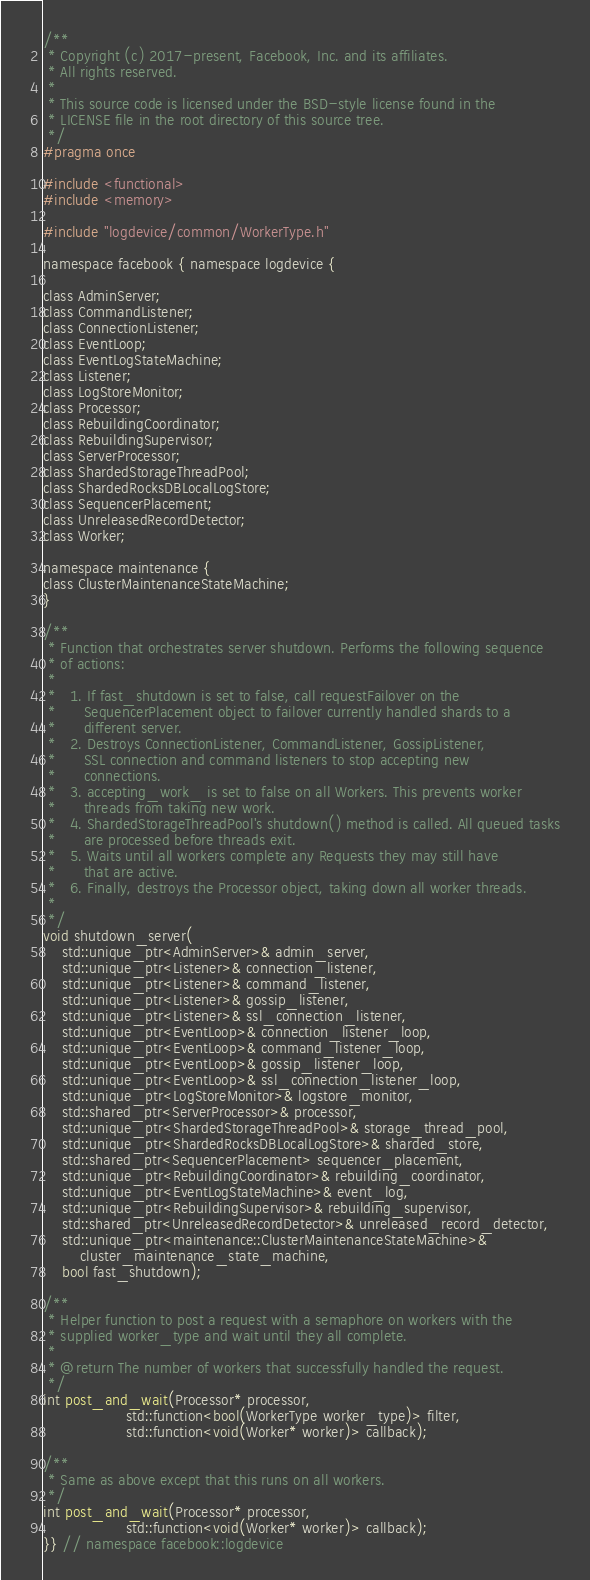<code> <loc_0><loc_0><loc_500><loc_500><_C_>/**
 * Copyright (c) 2017-present, Facebook, Inc. and its affiliates.
 * All rights reserved.
 *
 * This source code is licensed under the BSD-style license found in the
 * LICENSE file in the root directory of this source tree.
 */
#pragma once

#include <functional>
#include <memory>

#include "logdevice/common/WorkerType.h"

namespace facebook { namespace logdevice {

class AdminServer;
class CommandListener;
class ConnectionListener;
class EventLoop;
class EventLogStateMachine;
class Listener;
class LogStoreMonitor;
class Processor;
class RebuildingCoordinator;
class RebuildingSupervisor;
class ServerProcessor;
class ShardedStorageThreadPool;
class ShardedRocksDBLocalLogStore;
class SequencerPlacement;
class UnreleasedRecordDetector;
class Worker;

namespace maintenance {
class ClusterMaintenanceStateMachine;
}

/**
 * Function that orchestrates server shutdown. Performs the following sequence
 * of actions:
 *
 *   1. If fast_shutdown is set to false, call requestFailover on the
 *      SequencerPlacement object to failover currently handled shards to a
 *      different server.
 *   2. Destroys ConnectionListener, CommandListener, GossipListener,
 *      SSL connection and command listeners to stop accepting new
 *      connections.
 *   3. accepting_work_ is set to false on all Workers. This prevents worker
 *      threads from taking new work.
 *   4. ShardedStorageThreadPool's shutdown() method is called. All queued tasks
 *      are processed before threads exit.
 *   5. Waits until all workers complete any Requests they may still have
 *      that are active.
 *   6. Finally, destroys the Processor object, taking down all worker threads.
 *
 */
void shutdown_server(
    std::unique_ptr<AdminServer>& admin_server,
    std::unique_ptr<Listener>& connection_listener,
    std::unique_ptr<Listener>& command_listener,
    std::unique_ptr<Listener>& gossip_listener,
    std::unique_ptr<Listener>& ssl_connection_listener,
    std::unique_ptr<EventLoop>& connection_listener_loop,
    std::unique_ptr<EventLoop>& command_listener_loop,
    std::unique_ptr<EventLoop>& gossip_listener_loop,
    std::unique_ptr<EventLoop>& ssl_connection_listener_loop,
    std::unique_ptr<LogStoreMonitor>& logstore_monitor,
    std::shared_ptr<ServerProcessor>& processor,
    std::unique_ptr<ShardedStorageThreadPool>& storage_thread_pool,
    std::unique_ptr<ShardedRocksDBLocalLogStore>& sharded_store,
    std::shared_ptr<SequencerPlacement> sequencer_placement,
    std::unique_ptr<RebuildingCoordinator>& rebuilding_coordinator,
    std::unique_ptr<EventLogStateMachine>& event_log,
    std::unique_ptr<RebuildingSupervisor>& rebuilding_supervisor,
    std::shared_ptr<UnreleasedRecordDetector>& unreleased_record_detector,
    std::unique_ptr<maintenance::ClusterMaintenanceStateMachine>&
        cluster_maintenance_state_machine,
    bool fast_shutdown);

/**
 * Helper function to post a request with a semaphore on workers with the
 * supplied worker_type and wait until they all complete.
 *
 * @return The number of workers that successfully handled the request.
 */
int post_and_wait(Processor* processor,
                  std::function<bool(WorkerType worker_type)> filter,
                  std::function<void(Worker* worker)> callback);

/**
 * Same as above except that this runs on all workers.
 */
int post_and_wait(Processor* processor,
                  std::function<void(Worker* worker)> callback);
}} // namespace facebook::logdevice
</code> 